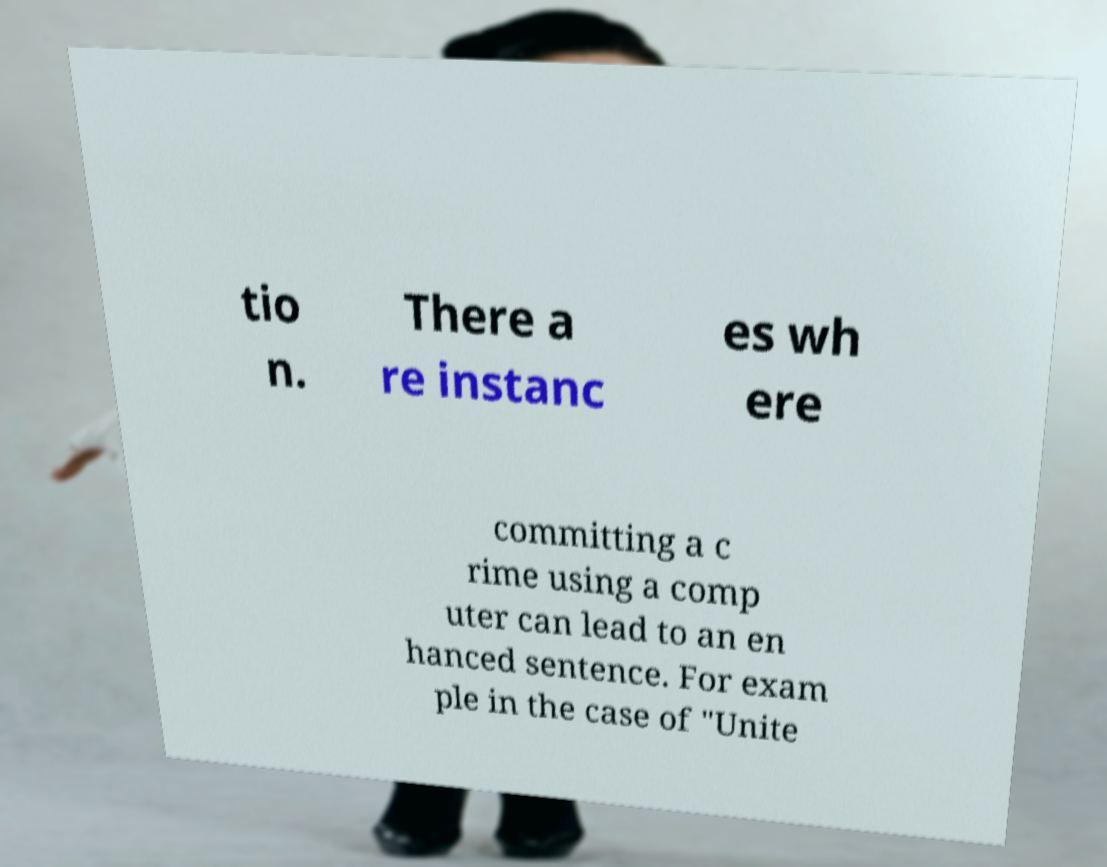Can you accurately transcribe the text from the provided image for me? tio n. There a re instanc es wh ere committing a c rime using a comp uter can lead to an en hanced sentence. For exam ple in the case of "Unite 